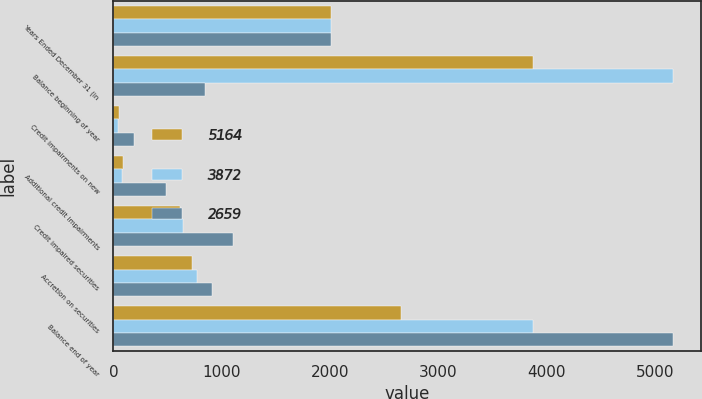Convert chart to OTSL. <chart><loc_0><loc_0><loc_500><loc_500><stacked_bar_chart><ecel><fcel>Years Ended December 31 (in<fcel>Balance beginning of year<fcel>Credit impairments on new<fcel>Additional credit impairments<fcel>Credit impaired securities<fcel>Accretion on securities<fcel>Balance end of year<nl><fcel>5164<fcel>2014<fcel>3872<fcel>49<fcel>85<fcel>613<fcel>725<fcel>2659<nl><fcel>3872<fcel>2013<fcel>5164<fcel>47<fcel>78<fcel>643<fcel>774<fcel>3872<nl><fcel>2659<fcel>2012<fcel>844.5<fcel>194<fcel>483<fcel>1105<fcel>915<fcel>5164<nl></chart> 